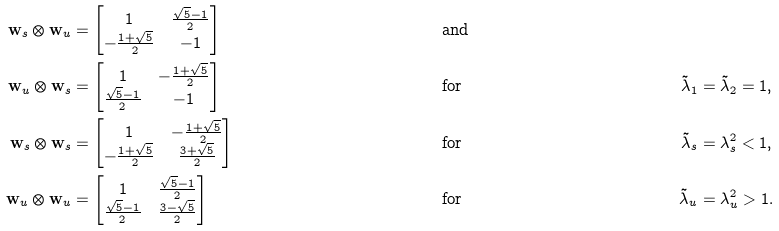<formula> <loc_0><loc_0><loc_500><loc_500>{ \mathbf w } _ { s } \otimes { \mathbf w } _ { u } & = \begin{bmatrix} 1 & \frac { \sqrt { 5 } - 1 } { 2 } \\ - \frac { 1 + \sqrt { 5 } } { 2 } & - 1 \end{bmatrix} & & \text {and} & & \\ { \mathbf w } _ { u } \otimes { \mathbf w } _ { s } & = \begin{bmatrix} 1 & - \frac { 1 + \sqrt { 5 } } { 2 } \\ \frac { \sqrt { 5 } - 1 } { 2 } & - 1 \end{bmatrix} & & \text {for} & \tilde { \lambda } _ { 1 } & = \tilde { \lambda } _ { 2 } = 1 , \\ { \mathbf w } _ { s } \otimes { \mathbf w } _ { s } & = \begin{bmatrix} 1 & - \frac { 1 + \sqrt { 5 } } { 2 } \\ - \frac { 1 + \sqrt { 5 } } { 2 } & \frac { 3 + \sqrt { 5 } } { 2 } \end{bmatrix} & & \text {for} & \tilde { \lambda } _ { s } & = \lambda _ { s } ^ { 2 } < 1 , \\ { \mathbf w } _ { u } \otimes { \mathbf w } _ { u } & = \begin{bmatrix} 1 & \frac { \sqrt { 5 } - 1 } { 2 } \\ \frac { \sqrt { 5 } - 1 } { 2 } & \frac { 3 - \sqrt { 5 } } { 2 } \end{bmatrix} & & \text {for} & \tilde { \lambda } _ { u } & = \lambda _ { u } ^ { 2 } > 1 .</formula> 